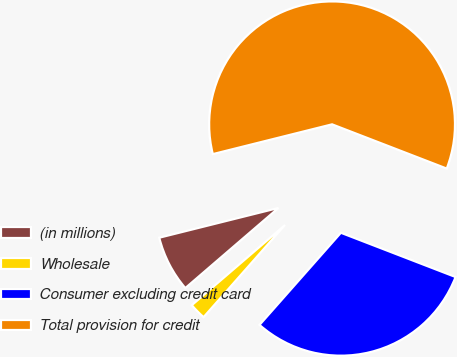Convert chart. <chart><loc_0><loc_0><loc_500><loc_500><pie_chart><fcel>(in millions)<fcel>Wholesale<fcel>Consumer excluding credit card<fcel>Total provision for credit<nl><fcel>7.41%<fcel>2.18%<fcel>30.65%<fcel>59.75%<nl></chart> 